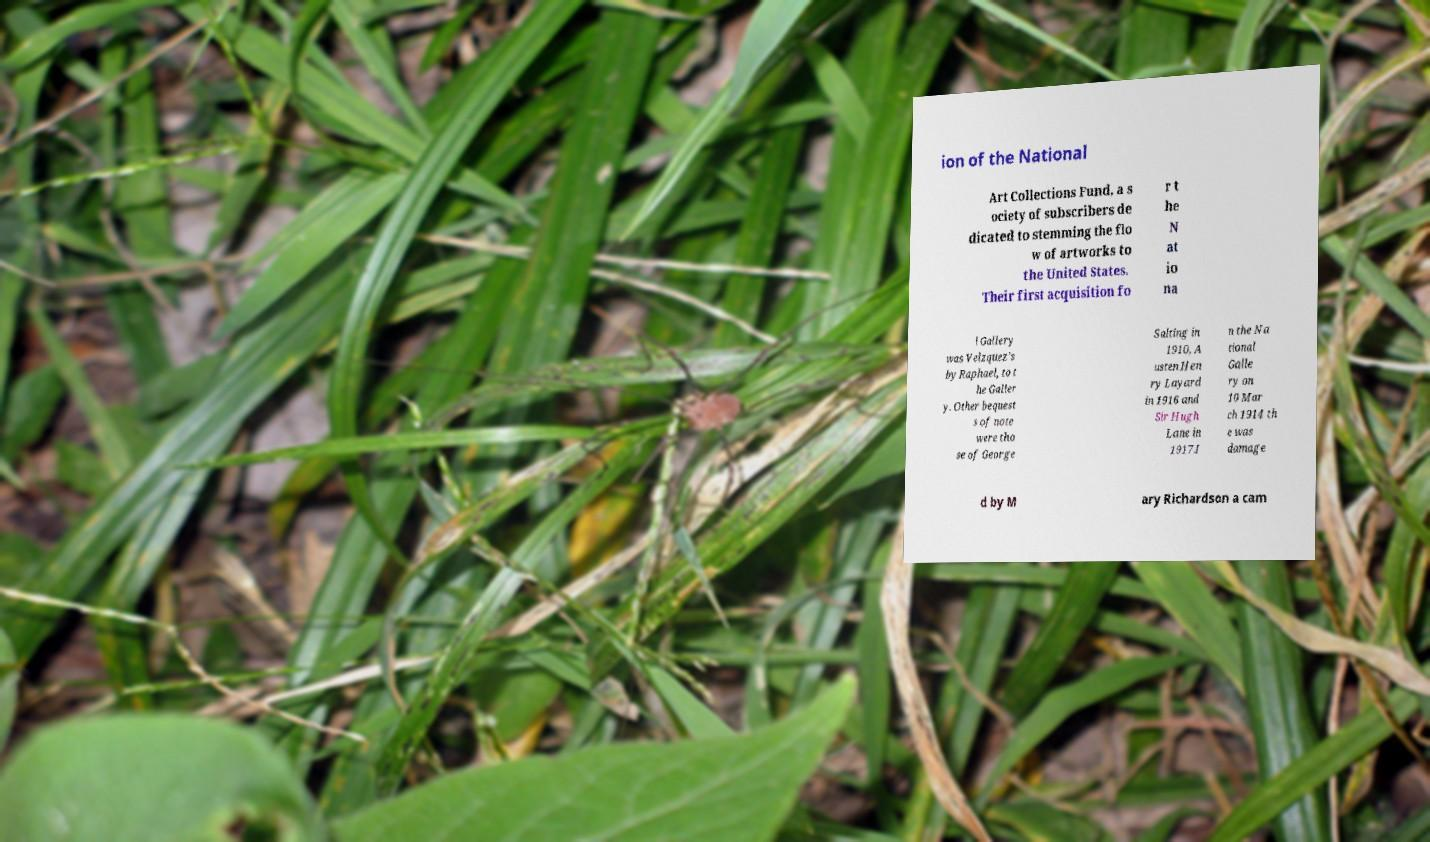I need the written content from this picture converted into text. Can you do that? ion of the National Art Collections Fund, a s ociety of subscribers de dicated to stemming the flo w of artworks to the United States. Their first acquisition fo r t he N at io na l Gallery was Velzquez's by Raphael, to t he Galler y. Other bequest s of note were tho se of George Salting in 1910, A usten Hen ry Layard in 1916 and Sir Hugh Lane in 1917.I n the Na tional Galle ry on 10 Mar ch 1914 th e was damage d by M ary Richardson a cam 